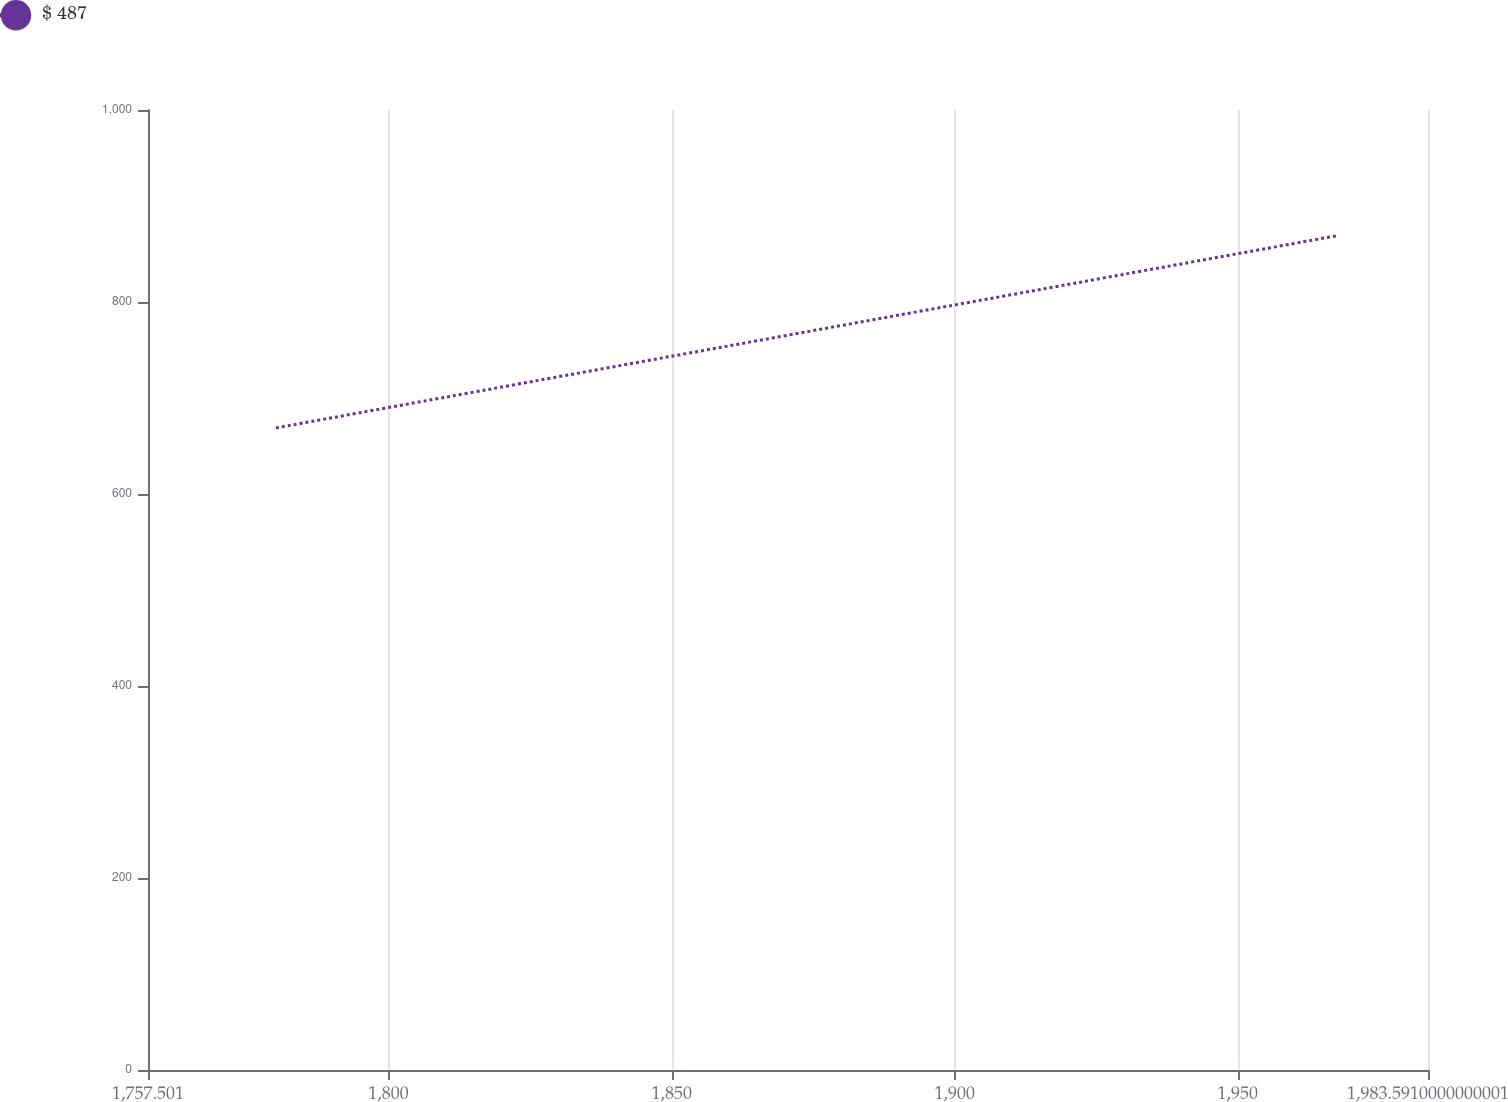Convert chart to OTSL. <chart><loc_0><loc_0><loc_500><loc_500><line_chart><ecel><fcel>$ 487<nl><fcel>1780.11<fcel>668.85<nl><fcel>1967.72<fcel>869.26<nl><fcel>1986.96<fcel>922.96<nl><fcel>2006.2<fcel>765.62<nl></chart> 